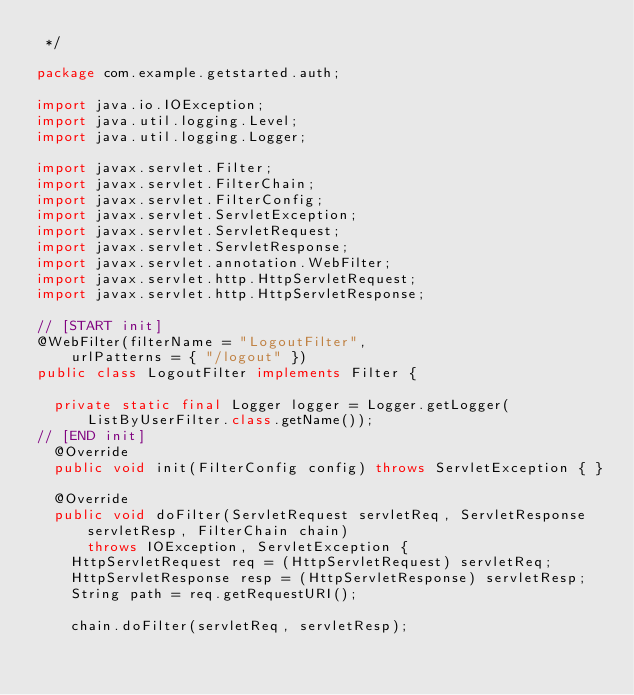<code> <loc_0><loc_0><loc_500><loc_500><_Java_> */

package com.example.getstarted.auth;

import java.io.IOException;
import java.util.logging.Level;
import java.util.logging.Logger;

import javax.servlet.Filter;
import javax.servlet.FilterChain;
import javax.servlet.FilterConfig;
import javax.servlet.ServletException;
import javax.servlet.ServletRequest;
import javax.servlet.ServletResponse;
import javax.servlet.annotation.WebFilter;
import javax.servlet.http.HttpServletRequest;
import javax.servlet.http.HttpServletResponse;

// [START init]
@WebFilter(filterName = "LogoutFilter",
    urlPatterns = { "/logout" })
public class LogoutFilter implements Filter {

  private static final Logger logger = Logger.getLogger(ListByUserFilter.class.getName());
// [END init]
  @Override
  public void init(FilterConfig config) throws ServletException { }

  @Override
  public void doFilter(ServletRequest servletReq, ServletResponse servletResp, FilterChain chain)
      throws IOException, ServletException {
    HttpServletRequest req = (HttpServletRequest) servletReq;
    HttpServletResponse resp = (HttpServletResponse) servletResp;
    String path = req.getRequestURI();

    chain.doFilter(servletReq, servletResp);
</code> 